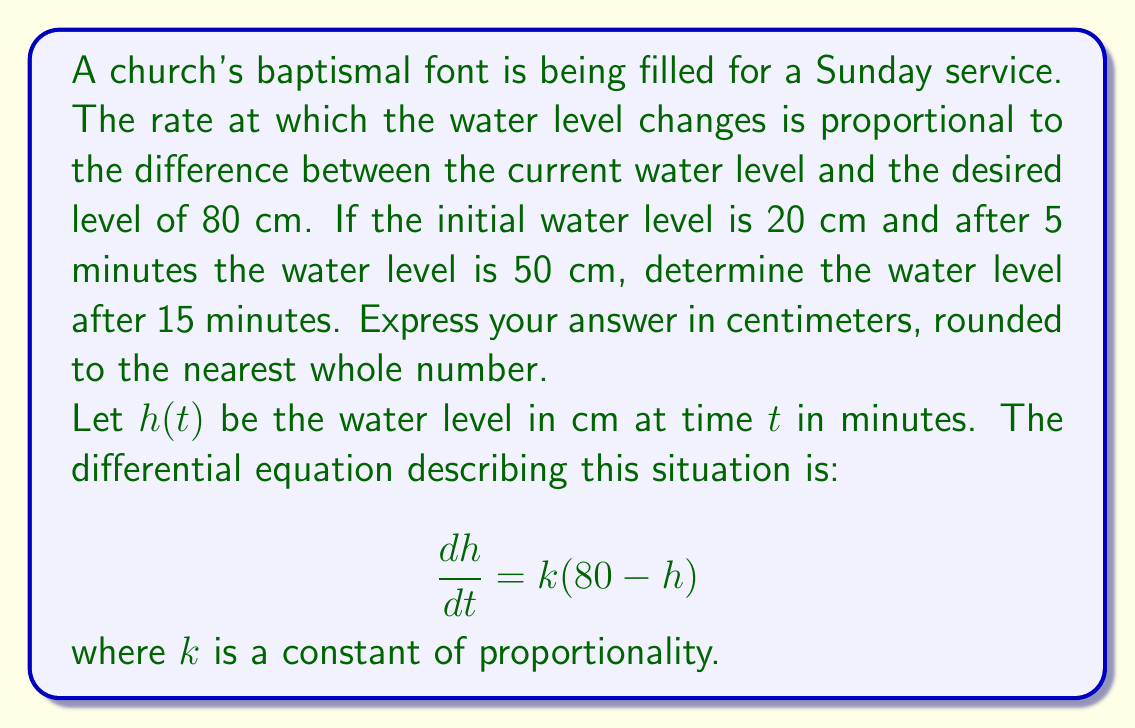Can you solve this math problem? To solve this problem, we'll follow these steps:

1) First, we need to solve the differential equation:
   $$\frac{dh}{dt} = k(80 - h)$$

   This is a separable equation. Rearranging and integrating both sides:
   $$\int \frac{dh}{80 - h} = \int k dt$$
   $$-\ln|80 - h| = kt + C$$
   $$80 - h = Ae^{-kt}$$
   $$h = 80 - Ae^{-kt}$$

2) Now we use the initial condition: when $t = 0$, $h = 20$
   $$20 = 80 - A$$
   $$A = 60$$

   So our solution is: $h = 80 - 60e^{-kt}$

3) We can find $k$ using the condition that at $t = 5$, $h = 50$:
   $$50 = 80 - 60e^{-5k}$$
   $$30 = 60e^{-5k}$$
   $$\frac{1}{2} = e^{-5k}$$
   $$\ln(\frac{1}{2}) = -5k$$
   $$k = \frac{\ln(2)}{5} \approx 0.1386$$

4) Now we have our complete solution:
   $$h = 80 - 60e^{-0.1386t}$$

5) To find the water level after 15 minutes, we substitute $t = 15$:
   $$h(15) = 80 - 60e^{-0.1386(15)} \approx 71.8 \text{ cm}$$
Answer: 72 cm 